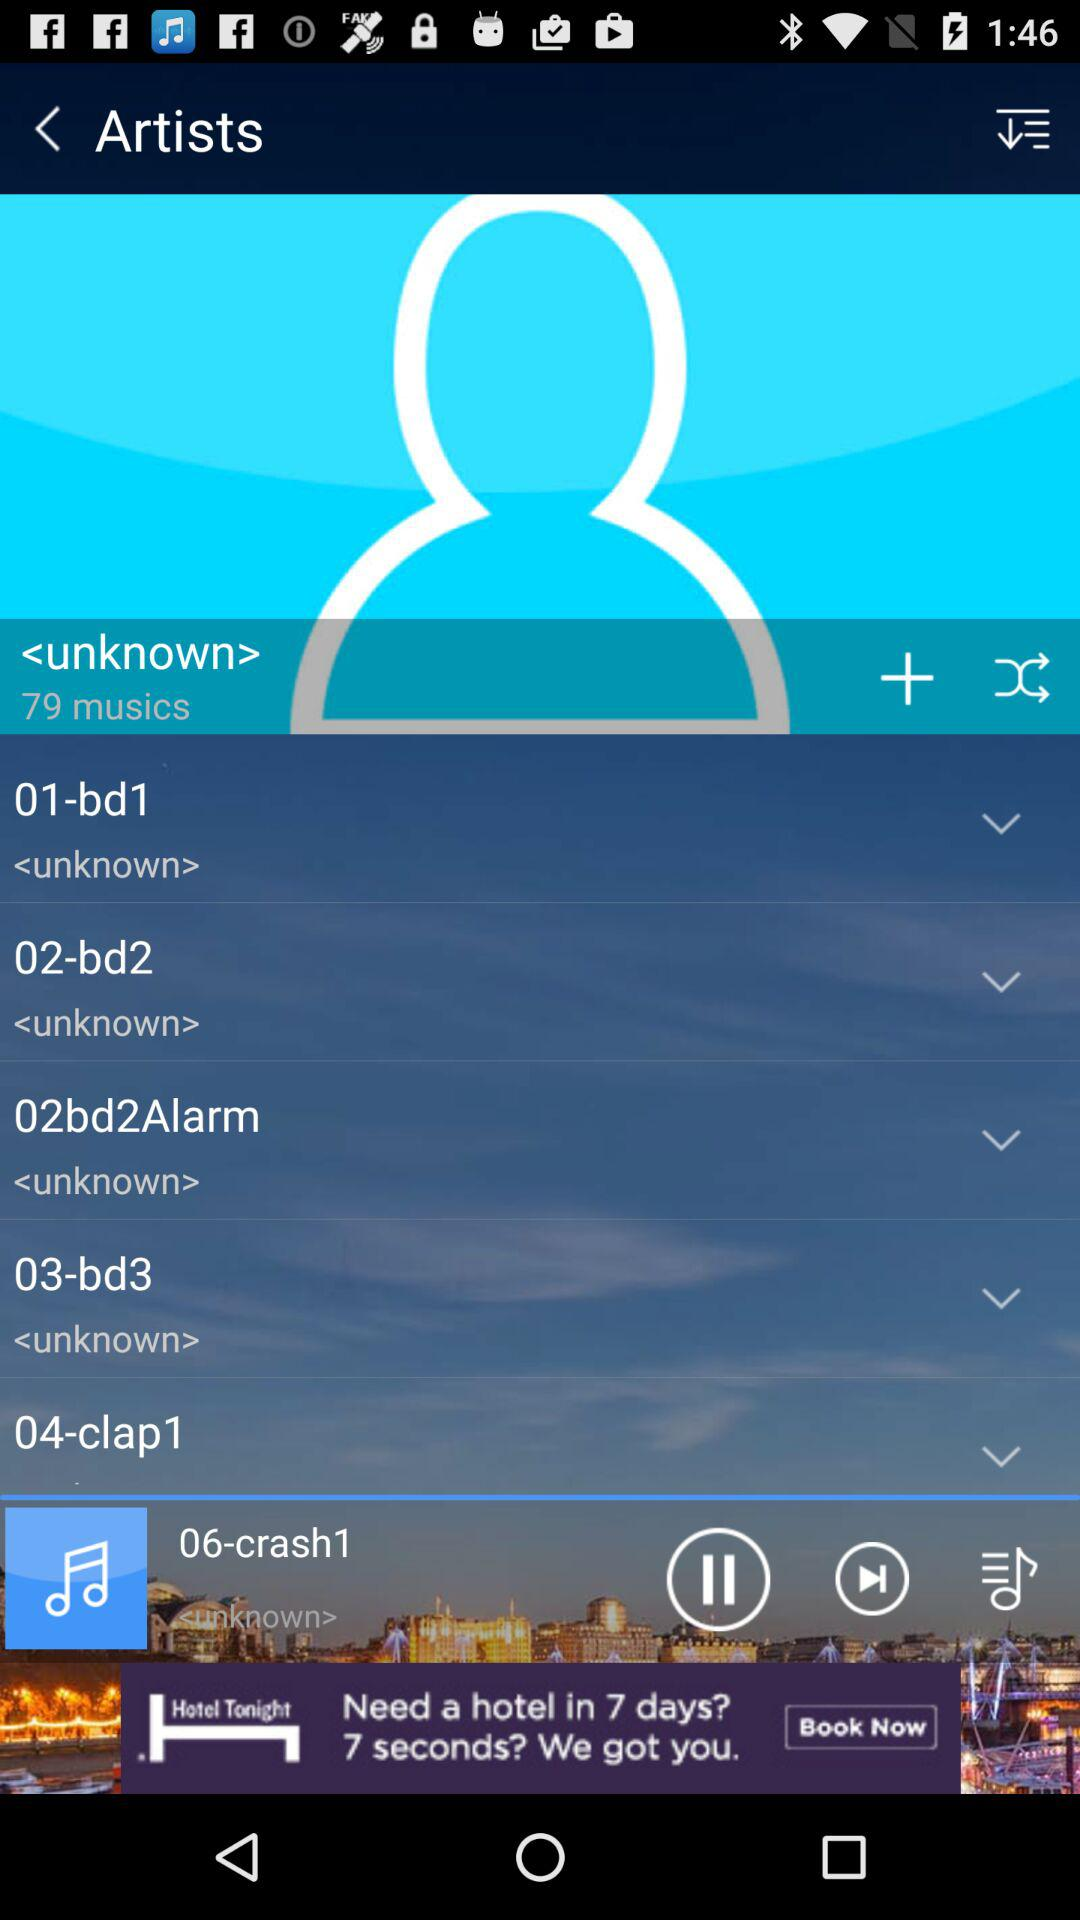How many musics are there in total?
Answer the question using a single word or phrase. 79 